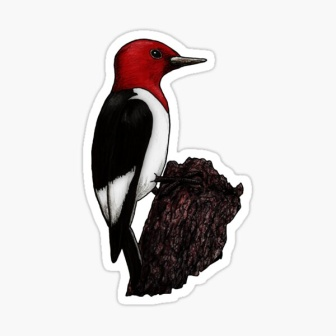Describe the different textures you can observe in the image. The image showcases various textures that add depth and realism to the scene. The red-headed woodpecker's feathers appear soft and smooth, especially noticeable in the contrasting red and black areas. The white chest area has a more subtle texture, adding to the diversity. In contrast, the tree stump is rugged and rough, with clear bark patterns and a noticeable protruding branch, giving it an authentic, aged look. The combination of smooth feathers against the coarse tree bark creates a striking tactile contrast that enhances the visual interest of the image. 